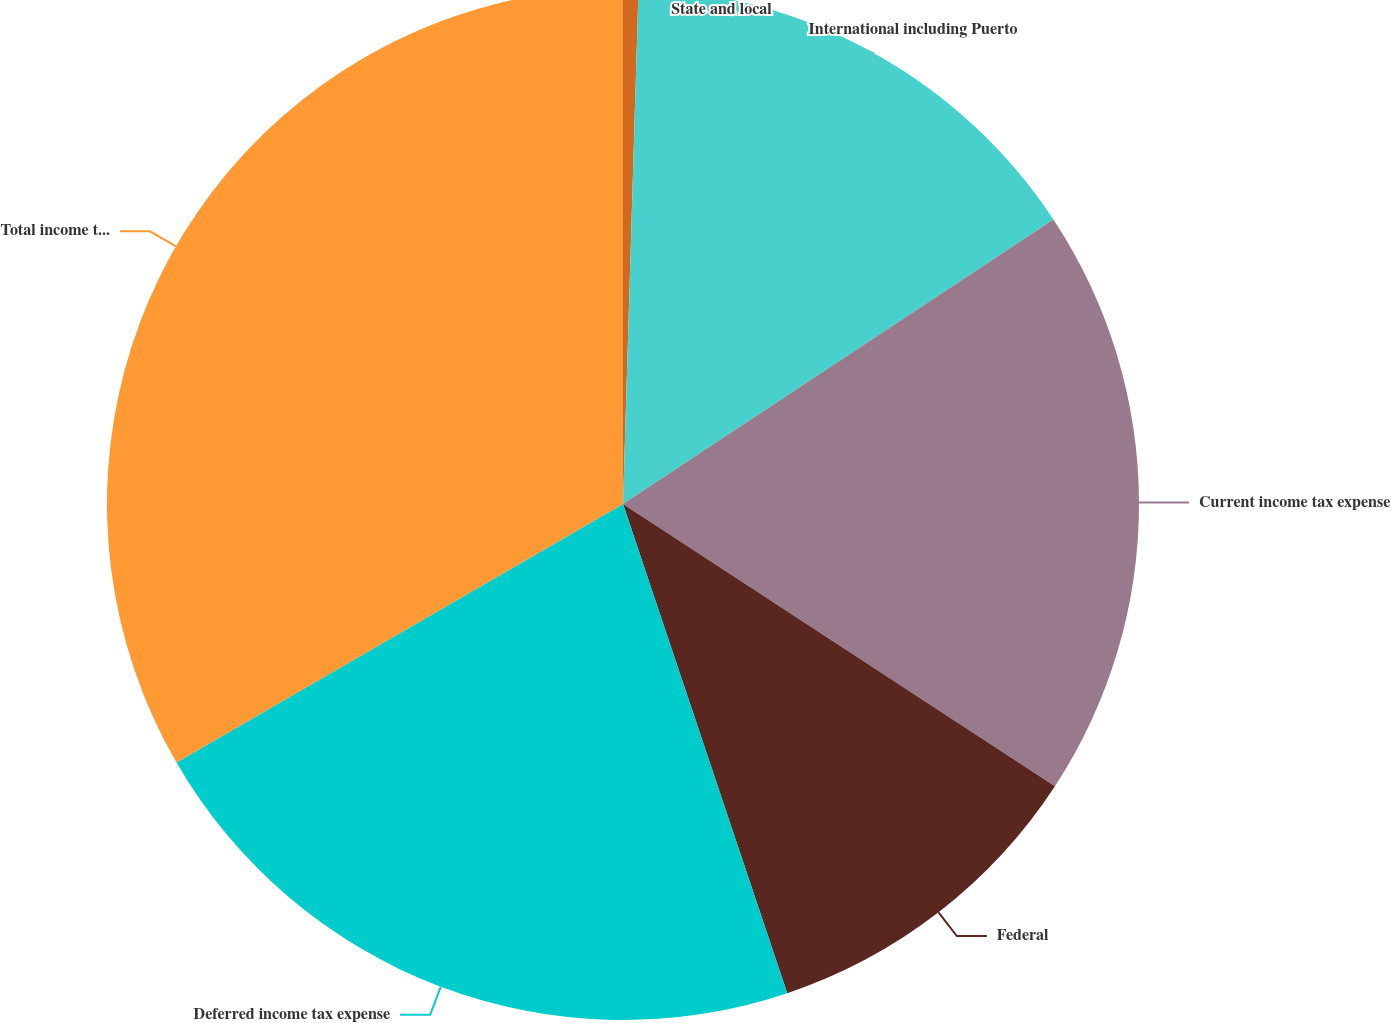Convert chart to OTSL. <chart><loc_0><loc_0><loc_500><loc_500><pie_chart><fcel>State and local<fcel>International including Puerto<fcel>Current income tax expense<fcel>Federal<fcel>Deferred income tax expense<fcel>Total income tax expense<nl><fcel>0.48%<fcel>15.22%<fcel>18.51%<fcel>10.63%<fcel>21.8%<fcel>33.35%<nl></chart> 